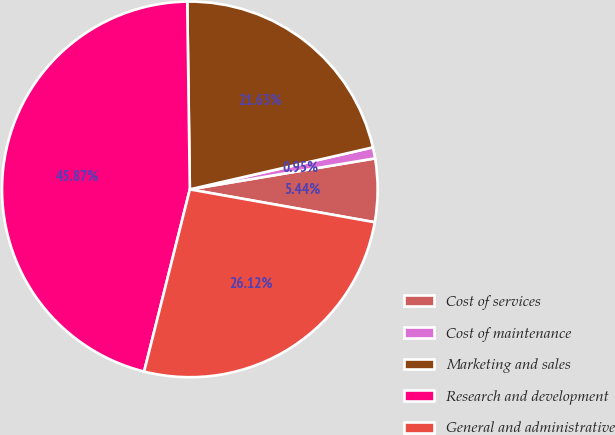Convert chart to OTSL. <chart><loc_0><loc_0><loc_500><loc_500><pie_chart><fcel>Cost of services<fcel>Cost of maintenance<fcel>Marketing and sales<fcel>Research and development<fcel>General and administrative<nl><fcel>5.44%<fcel>0.95%<fcel>21.63%<fcel>45.87%<fcel>26.12%<nl></chart> 